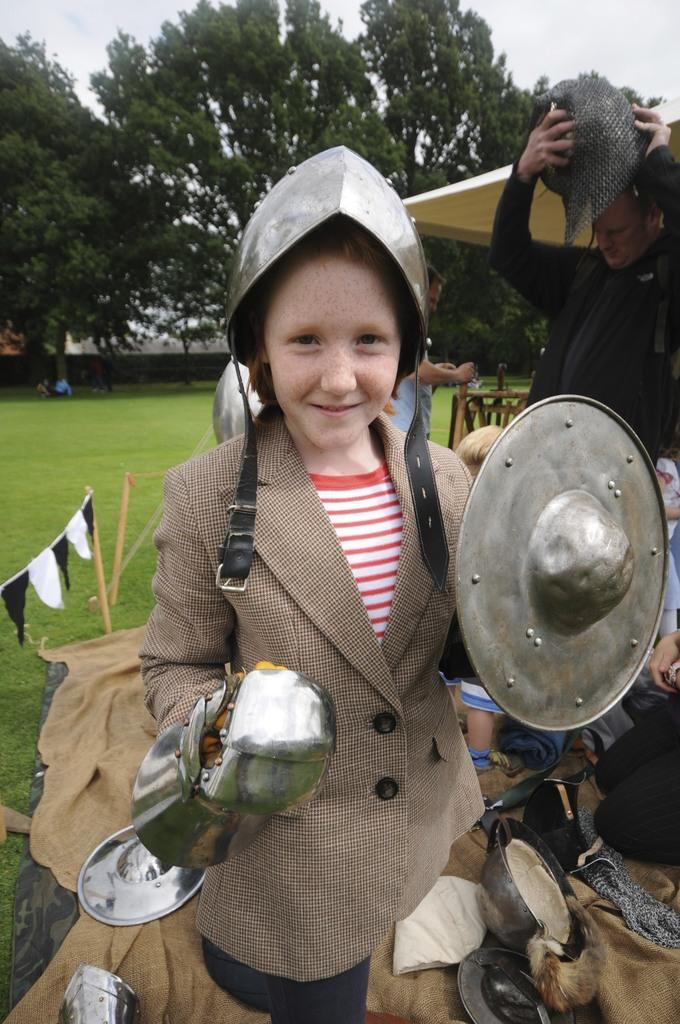What is the main subject of the image? There is a kid in a costume in the image. What can be seen behind the kid? There is a stall behind the kid. Are there any people visible in the image? Yes, there are people behind the stall. What type of natural environment is visible in the background of the image? There is grass, trees, and the sky visible in the background of the image. What type of industry is depicted in the image? There is no industry depicted in the image; it features a kid in a costume, a stall, and people in a natural environment. Can you tell me how many letters are visible on the stall in the image? There is no mention of letters on the stall in the provided facts, so it cannot be determined from the image. 